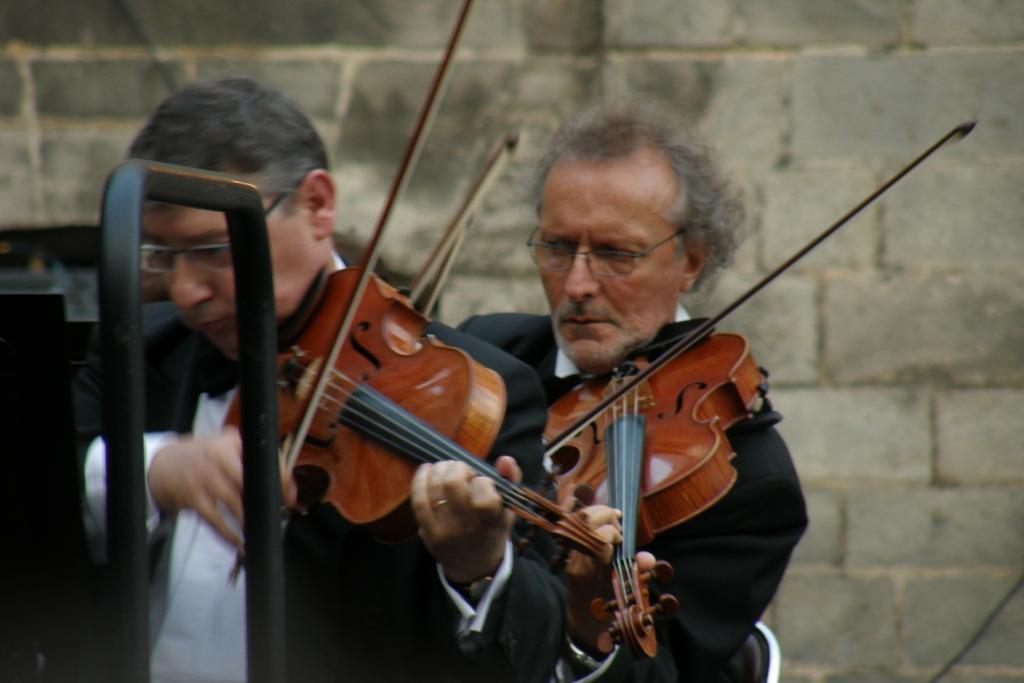In one or two sentences, can you explain what this image depicts? Two musicians are playing violin. 